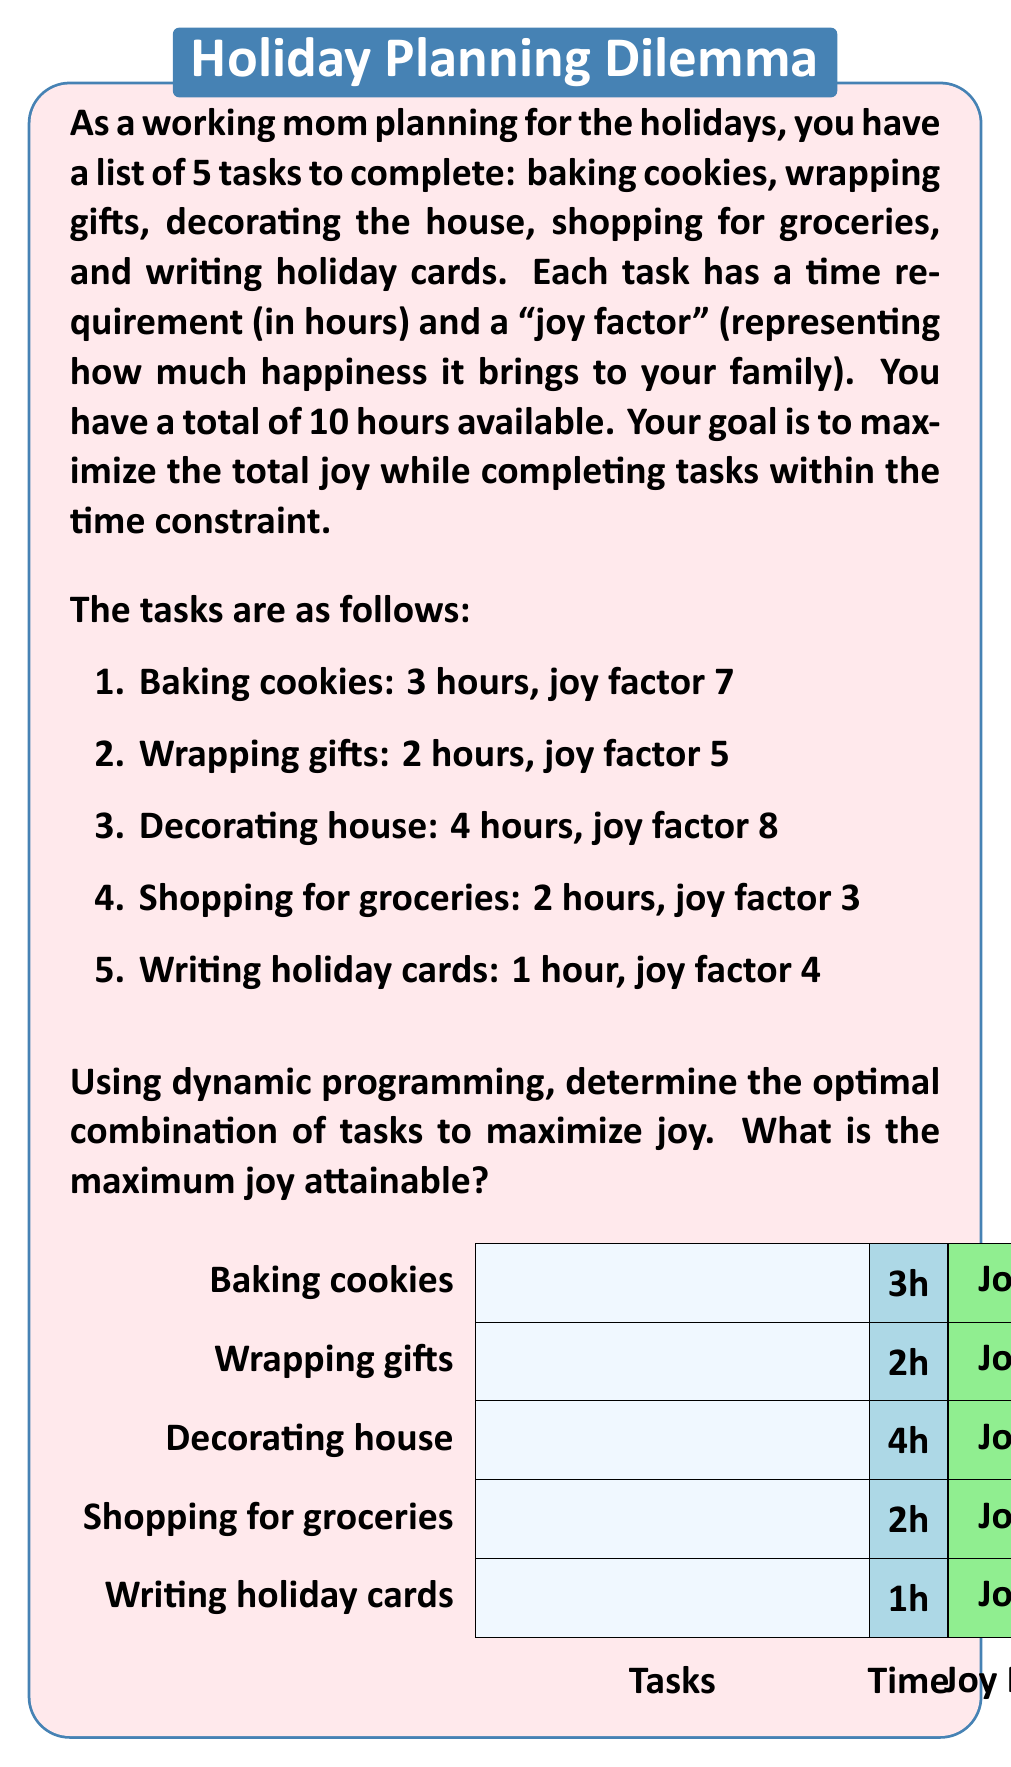Help me with this question. To solve this problem using dynamic programming, we'll create a table where rows represent the tasks and columns represent the available time (0 to 10 hours). Each cell will contain the maximum joy attainable for the given time using the tasks up to that row.

Let's define our dynamic programming function:

$$dp[i][j] = \max(\text{joy of including task i} + dp[i-1][j-\text{time of task i}], dp[i-1][j])$$

Where $i$ is the current task and $j$ is the available time.

Step 1: Initialize the DP table
Create a 6x11 table (0-5 tasks, 0-10 hours) and fill the first row and column with zeros.

Step 2: Fill the DP table
For each task i (1 to 5) and each time j (0 to 10):
- If the task can fit in the current time (time[i] <= j), consider including it.
- Compare the joy of including the task with the joy of not including it.
- Choose the maximum of these two options.

Step 3: Fill the table row by row
Row 1 (Baking cookies):
For j >= 3: dp[1][j] = 7 (include the task)
For j < 3: dp[1][j] = 0 (can't include the task)

Row 2 (Wrapping gifts):
For j >= 2: dp[2][j] = max(5 + dp[1][j-2], dp[1][j])
For j < 2: dp[2][j] = dp[1][j]

Continue this process for rows 3, 4, and 5.

Step 4: The final answer
The maximum joy attainable is the value in dp[5][10], which represents the maximum joy achievable using all tasks within 10 hours.

The completed DP table (showing only the last row):
$$
\begin{array}{c|ccccccccccc}
\text{Hours} & 0 & 1 & 2 & 3 & 4 & 5 & 6 & 7 & 8 & 9 & 10 \\
\hline
\text{Max Joy} & 0 & 4 & 5 & 7 & 9 & 11 & 12 & 16 & 17 & 19 & 20
\end{array}
$$

To determine which tasks were selected, we can backtrack through the table.
Answer: 20 